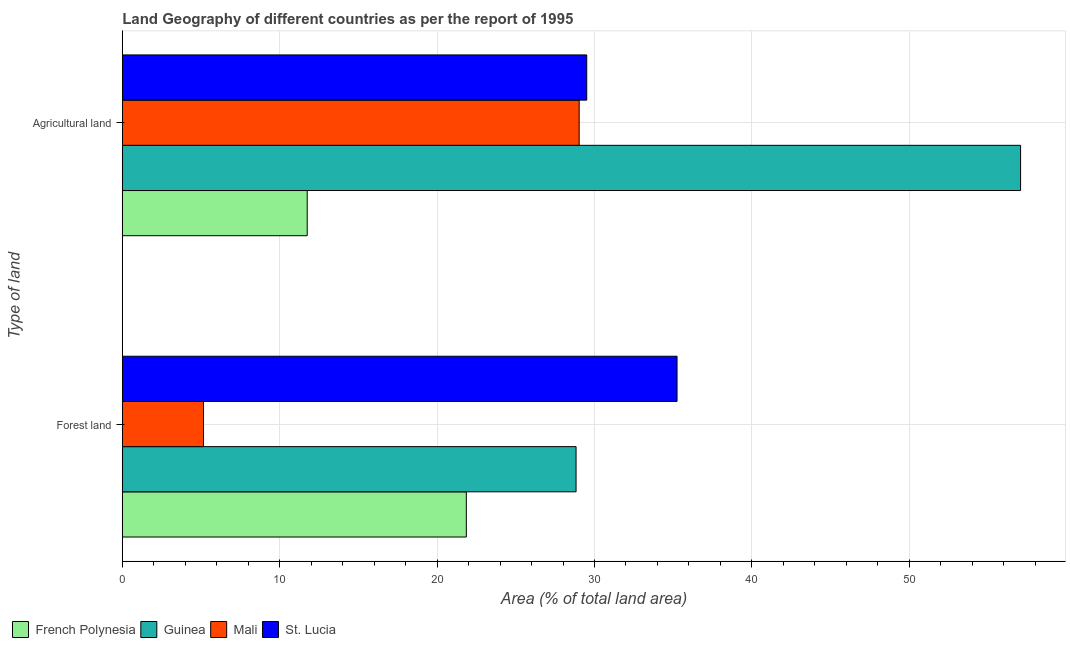How many different coloured bars are there?
Provide a short and direct response. 4. How many groups of bars are there?
Provide a succinct answer. 2. How many bars are there on the 1st tick from the top?
Offer a terse response. 4. How many bars are there on the 1st tick from the bottom?
Provide a short and direct response. 4. What is the label of the 1st group of bars from the top?
Your answer should be compact. Agricultural land. What is the percentage of land area under forests in Guinea?
Offer a terse response. 28.83. Across all countries, what is the maximum percentage of land area under forests?
Keep it short and to the point. 35.25. Across all countries, what is the minimum percentage of land area under agriculture?
Your answer should be very brief. 11.75. In which country was the percentage of land area under agriculture maximum?
Keep it short and to the point. Guinea. In which country was the percentage of land area under agriculture minimum?
Your response must be concise. French Polynesia. What is the total percentage of land area under forests in the graph?
Your answer should be very brief. 91.09. What is the difference between the percentage of land area under forests in French Polynesia and that in Mali?
Give a very brief answer. 16.7. What is the difference between the percentage of land area under forests in Mali and the percentage of land area under agriculture in Guinea?
Offer a terse response. -51.91. What is the average percentage of land area under agriculture per country?
Provide a succinct answer. 31.84. What is the difference between the percentage of land area under forests and percentage of land area under agriculture in French Polynesia?
Keep it short and to the point. 10.11. What is the ratio of the percentage of land area under agriculture in St. Lucia to that in French Polynesia?
Your response must be concise. 2.51. Is the percentage of land area under agriculture in French Polynesia less than that in St. Lucia?
Offer a very short reply. Yes. What does the 4th bar from the top in Forest land represents?
Your answer should be very brief. French Polynesia. What does the 2nd bar from the bottom in Agricultural land represents?
Give a very brief answer. Guinea. Are all the bars in the graph horizontal?
Your answer should be very brief. Yes. How many countries are there in the graph?
Keep it short and to the point. 4. Where does the legend appear in the graph?
Provide a short and direct response. Bottom left. How many legend labels are there?
Make the answer very short. 4. How are the legend labels stacked?
Give a very brief answer. Horizontal. What is the title of the graph?
Offer a terse response. Land Geography of different countries as per the report of 1995. Does "Mauritius" appear as one of the legend labels in the graph?
Offer a very short reply. No. What is the label or title of the X-axis?
Provide a succinct answer. Area (% of total land area). What is the label or title of the Y-axis?
Provide a short and direct response. Type of land. What is the Area (% of total land area) of French Polynesia in Forest land?
Give a very brief answer. 21.86. What is the Area (% of total land area) of Guinea in Forest land?
Give a very brief answer. 28.83. What is the Area (% of total land area) in Mali in Forest land?
Your answer should be very brief. 5.16. What is the Area (% of total land area) in St. Lucia in Forest land?
Your response must be concise. 35.25. What is the Area (% of total land area) in French Polynesia in Agricultural land?
Your answer should be compact. 11.75. What is the Area (% of total land area) of Guinea in Agricultural land?
Offer a very short reply. 57.07. What is the Area (% of total land area) in Mali in Agricultural land?
Ensure brevity in your answer.  29.03. What is the Area (% of total land area) of St. Lucia in Agricultural land?
Your answer should be compact. 29.51. Across all Type of land, what is the maximum Area (% of total land area) in French Polynesia?
Your answer should be compact. 21.86. Across all Type of land, what is the maximum Area (% of total land area) of Guinea?
Provide a succinct answer. 57.07. Across all Type of land, what is the maximum Area (% of total land area) of Mali?
Keep it short and to the point. 29.03. Across all Type of land, what is the maximum Area (% of total land area) in St. Lucia?
Ensure brevity in your answer.  35.25. Across all Type of land, what is the minimum Area (% of total land area) in French Polynesia?
Ensure brevity in your answer.  11.75. Across all Type of land, what is the minimum Area (% of total land area) in Guinea?
Ensure brevity in your answer.  28.83. Across all Type of land, what is the minimum Area (% of total land area) of Mali?
Provide a succinct answer. 5.16. Across all Type of land, what is the minimum Area (% of total land area) of St. Lucia?
Your answer should be very brief. 29.51. What is the total Area (% of total land area) of French Polynesia in the graph?
Provide a succinct answer. 33.61. What is the total Area (% of total land area) in Guinea in the graph?
Offer a terse response. 85.9. What is the total Area (% of total land area) in Mali in the graph?
Your answer should be very brief. 34.19. What is the total Area (% of total land area) of St. Lucia in the graph?
Provide a succinct answer. 64.75. What is the difference between the Area (% of total land area) in French Polynesia in Forest land and that in Agricultural land?
Keep it short and to the point. 10.11. What is the difference between the Area (% of total land area) in Guinea in Forest land and that in Agricultural land?
Your response must be concise. -28.24. What is the difference between the Area (% of total land area) in Mali in Forest land and that in Agricultural land?
Your answer should be very brief. -23.87. What is the difference between the Area (% of total land area) in St. Lucia in Forest land and that in Agricultural land?
Ensure brevity in your answer.  5.74. What is the difference between the Area (% of total land area) of French Polynesia in Forest land and the Area (% of total land area) of Guinea in Agricultural land?
Provide a succinct answer. -35.22. What is the difference between the Area (% of total land area) in French Polynesia in Forest land and the Area (% of total land area) in Mali in Agricultural land?
Make the answer very short. -7.17. What is the difference between the Area (% of total land area) in French Polynesia in Forest land and the Area (% of total land area) in St. Lucia in Agricultural land?
Offer a very short reply. -7.65. What is the difference between the Area (% of total land area) of Guinea in Forest land and the Area (% of total land area) of Mali in Agricultural land?
Keep it short and to the point. -0.2. What is the difference between the Area (% of total land area) of Guinea in Forest land and the Area (% of total land area) of St. Lucia in Agricultural land?
Ensure brevity in your answer.  -0.68. What is the difference between the Area (% of total land area) of Mali in Forest land and the Area (% of total land area) of St. Lucia in Agricultural land?
Your answer should be compact. -24.35. What is the average Area (% of total land area) in French Polynesia per Type of land?
Ensure brevity in your answer.  16.8. What is the average Area (% of total land area) in Guinea per Type of land?
Offer a terse response. 42.95. What is the average Area (% of total land area) in Mali per Type of land?
Your answer should be compact. 17.09. What is the average Area (% of total land area) of St. Lucia per Type of land?
Keep it short and to the point. 32.38. What is the difference between the Area (% of total land area) of French Polynesia and Area (% of total land area) of Guinea in Forest land?
Your answer should be very brief. -6.97. What is the difference between the Area (% of total land area) of French Polynesia and Area (% of total land area) of Mali in Forest land?
Ensure brevity in your answer.  16.7. What is the difference between the Area (% of total land area) of French Polynesia and Area (% of total land area) of St. Lucia in Forest land?
Offer a terse response. -13.39. What is the difference between the Area (% of total land area) in Guinea and Area (% of total land area) in Mali in Forest land?
Offer a very short reply. 23.67. What is the difference between the Area (% of total land area) of Guinea and Area (% of total land area) of St. Lucia in Forest land?
Your answer should be compact. -6.42. What is the difference between the Area (% of total land area) of Mali and Area (% of total land area) of St. Lucia in Forest land?
Offer a terse response. -30.09. What is the difference between the Area (% of total land area) in French Polynesia and Area (% of total land area) in Guinea in Agricultural land?
Keep it short and to the point. -45.32. What is the difference between the Area (% of total land area) of French Polynesia and Area (% of total land area) of Mali in Agricultural land?
Offer a very short reply. -17.28. What is the difference between the Area (% of total land area) of French Polynesia and Area (% of total land area) of St. Lucia in Agricultural land?
Offer a terse response. -17.76. What is the difference between the Area (% of total land area) in Guinea and Area (% of total land area) in Mali in Agricultural land?
Provide a short and direct response. 28.05. What is the difference between the Area (% of total land area) in Guinea and Area (% of total land area) in St. Lucia in Agricultural land?
Make the answer very short. 27.56. What is the difference between the Area (% of total land area) in Mali and Area (% of total land area) in St. Lucia in Agricultural land?
Provide a short and direct response. -0.48. What is the ratio of the Area (% of total land area) in French Polynesia in Forest land to that in Agricultural land?
Ensure brevity in your answer.  1.86. What is the ratio of the Area (% of total land area) in Guinea in Forest land to that in Agricultural land?
Ensure brevity in your answer.  0.51. What is the ratio of the Area (% of total land area) of Mali in Forest land to that in Agricultural land?
Your response must be concise. 0.18. What is the ratio of the Area (% of total land area) in St. Lucia in Forest land to that in Agricultural land?
Provide a succinct answer. 1.19. What is the difference between the highest and the second highest Area (% of total land area) in French Polynesia?
Your response must be concise. 10.11. What is the difference between the highest and the second highest Area (% of total land area) in Guinea?
Provide a short and direct response. 28.24. What is the difference between the highest and the second highest Area (% of total land area) of Mali?
Keep it short and to the point. 23.87. What is the difference between the highest and the second highest Area (% of total land area) of St. Lucia?
Provide a short and direct response. 5.74. What is the difference between the highest and the lowest Area (% of total land area) in French Polynesia?
Offer a very short reply. 10.11. What is the difference between the highest and the lowest Area (% of total land area) of Guinea?
Ensure brevity in your answer.  28.24. What is the difference between the highest and the lowest Area (% of total land area) of Mali?
Make the answer very short. 23.87. What is the difference between the highest and the lowest Area (% of total land area) in St. Lucia?
Provide a succinct answer. 5.74. 